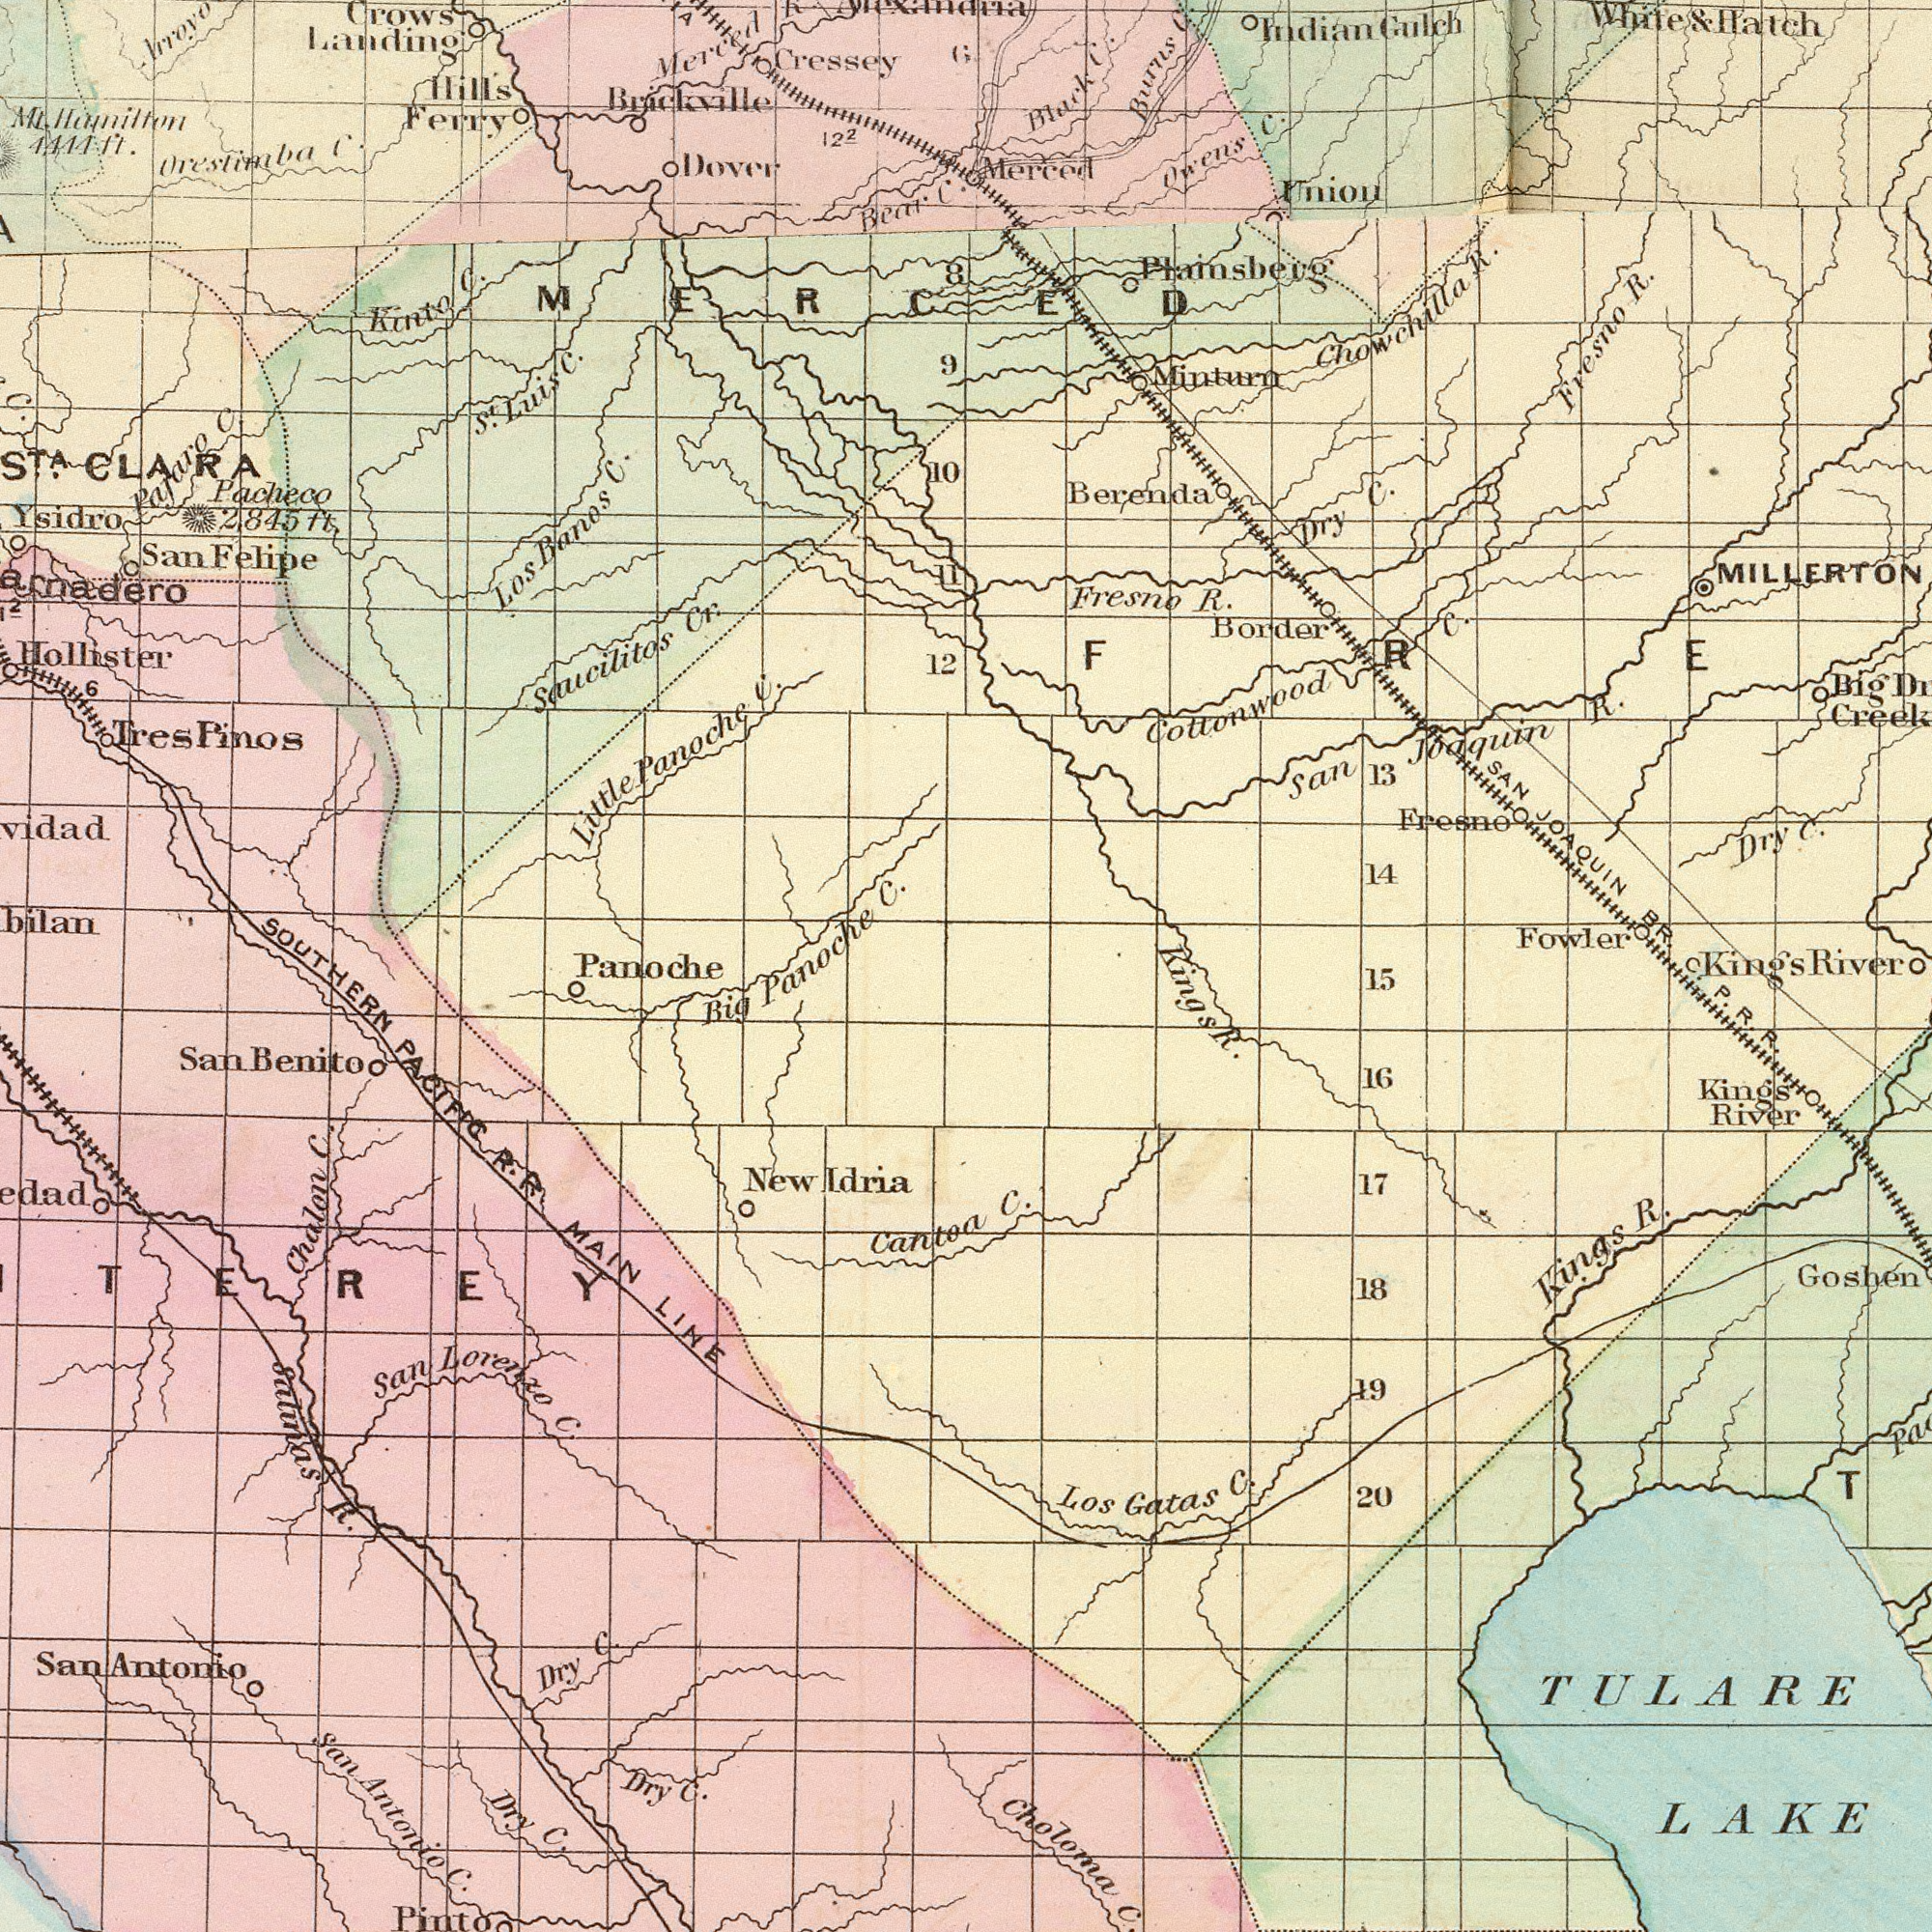What text is visible in the lower-right corner? C. P. R. R. C. Choloma TULARE LAKE Goshen Kings River Kings R. Los Gatas C. 16 19 20 T 17 18 15 Kings Kings R. What text can you see in the top-left section? Crows Landing Hollister Saucilitos Cr. Ysidro Mt. Hamilton 4444 ft. Cressey Bear C. Hills Ferry Orestimba C. Tres Pinos Los Banos C. Panoche C. San Felipe Brickville St Luis C. Kinto C. Little Panoche C. 12 Arroyo CLARA 10 Pacheco 2845 ft. MERCED Dover C. 122 Merced 9 11 8 Pajaro C. 6 6 What text is shown in the bottom-left quadrant? Big SOUTHERN PACIFIC R. R. MAIN LINE Salinas R. Chalon C. Dry C. Cantoa San Lorenzo C. New Idria San Antonio San Benito Dry C. Pinto San Antonio C. Dry C. Panoche What text appears in the top-right area of the image? Cottonwood C. Merced MILLERTON Fresno R. Berenda Chowchilla R. SAN JOAQUIN BR. San Joaquin R. Fowler Dry C. Uniou Minturn Owens C. Black C. Dry C. 14 13 Burns Cr. Fresno R. Indian Gulch Plainsberg Border Fresno White & Hatch Big River 